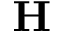<formula> <loc_0><loc_0><loc_500><loc_500>H</formula> 